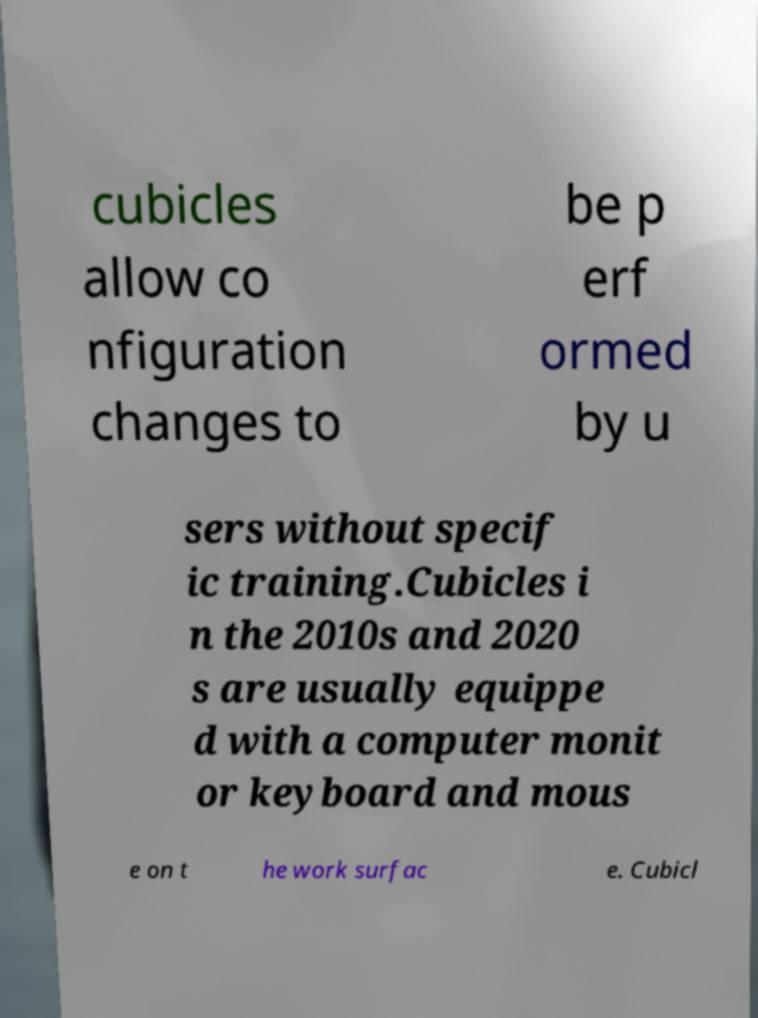Could you extract and type out the text from this image? cubicles allow co nfiguration changes to be p erf ormed by u sers without specif ic training.Cubicles i n the 2010s and 2020 s are usually equippe d with a computer monit or keyboard and mous e on t he work surfac e. Cubicl 